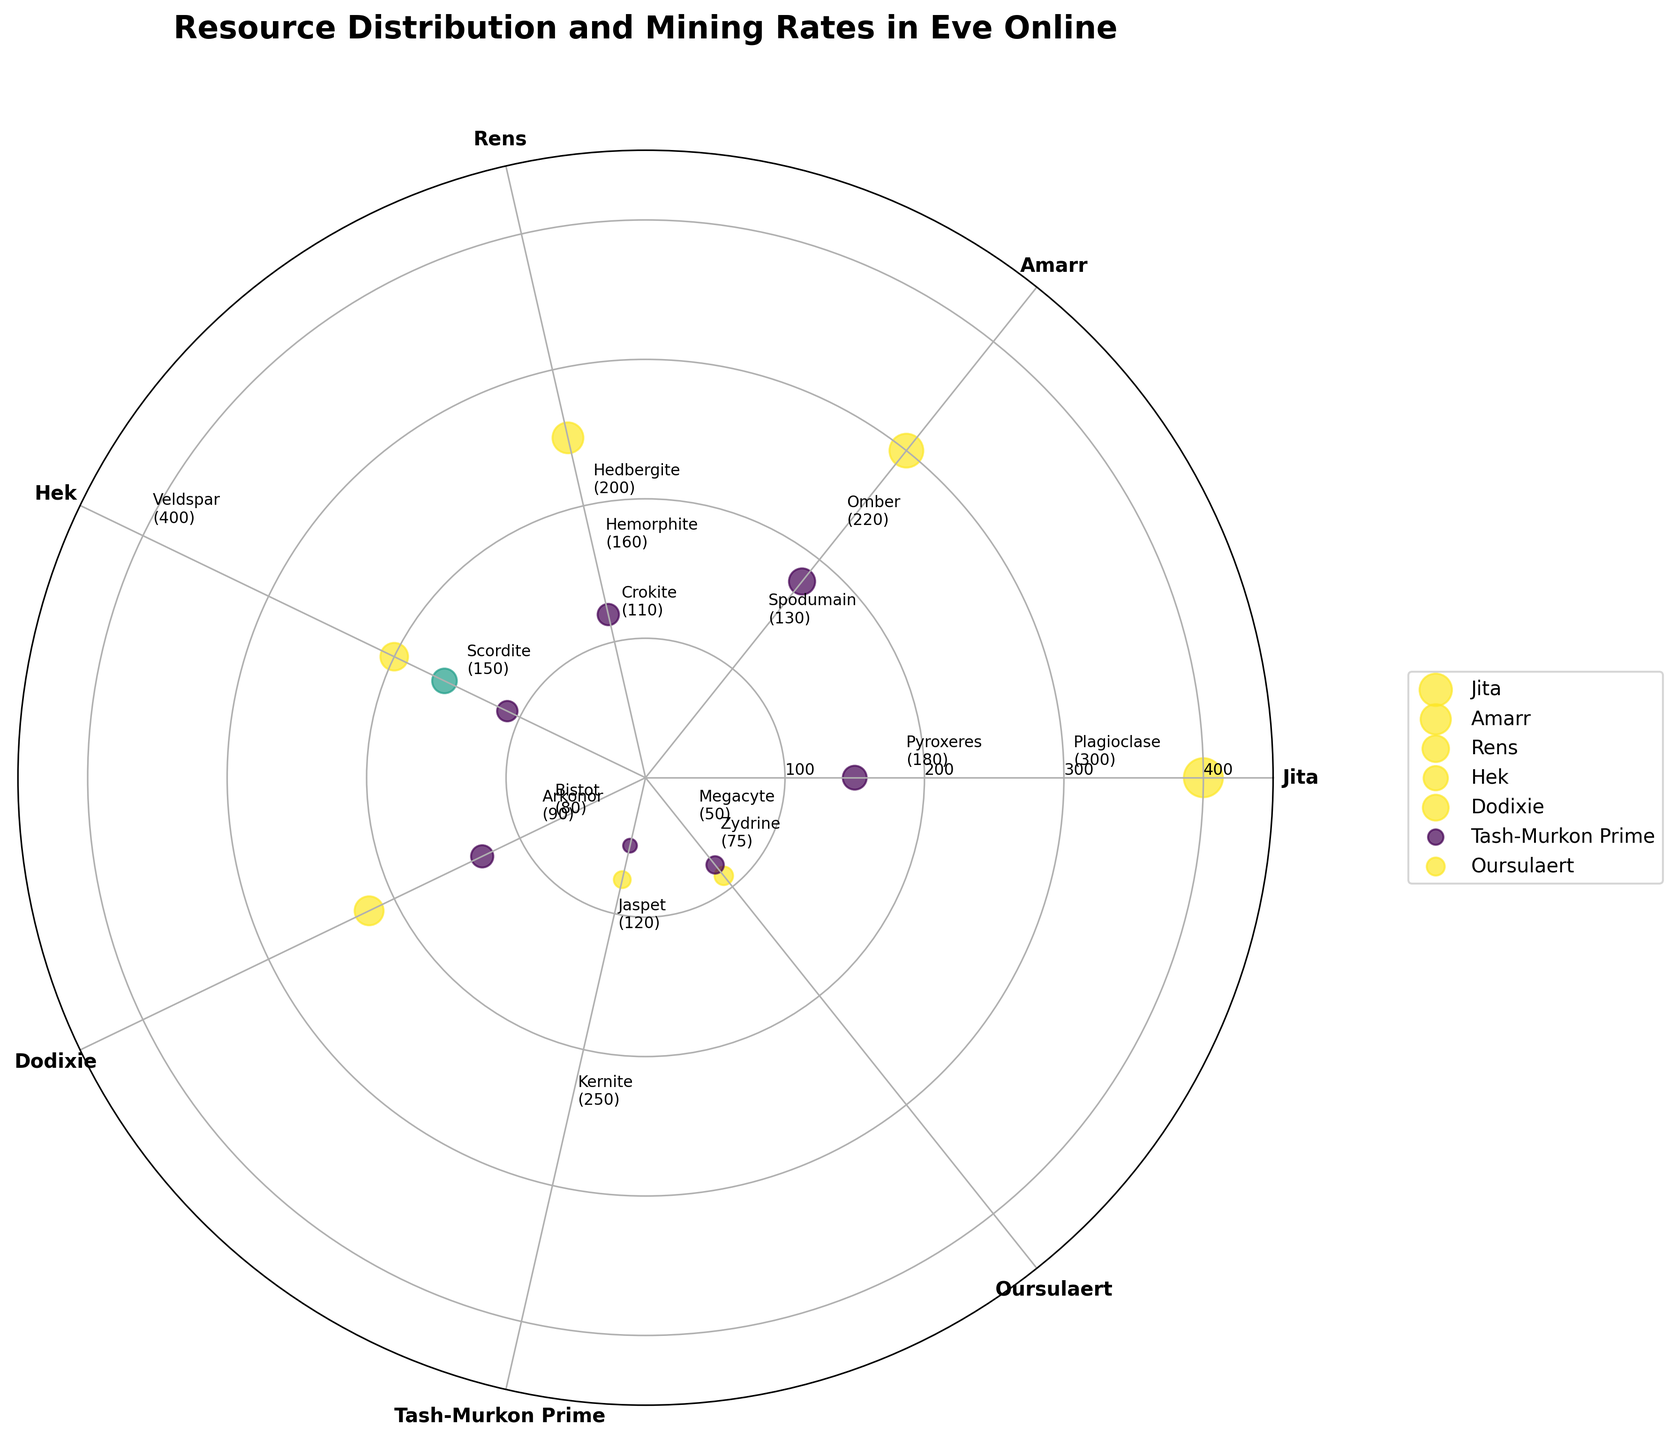What is the title of the plot? The title of the plot is clearly labeled at the top of the figure. It states: "Resource Distribution and Mining Rates in Eve Online".
Answer: Resource Distribution and Mining Rates in Eve Online Which star system has the highest mining rate for a single resource, and what is the rate? By examining the labels and values plotted around the circle, Jita has the highest mining rate for a single resource with Veldspar mined at a rate of 400.
Answer: Jita, 400 How many unique star systems are represented in the plot? The number of star systems can be determined by counting the different names on the circular axis. The unique star systems are Jita, Amarr, Rens, Hek, Dodixie, Tash-Murkon Prime, Oursulaert, resulting in seven unique star systems.
Answer: 7 What is the average mining rate for resources in Amarr? In Amarr, the resources are Plagioclase and Pyroxeres with mining rates of 300 and 180 respectively. The average mining rate is calculated as (300 + 180) / 2 = 240.
Answer: 240 Which resource has the lowest mining rate, and in which star system is it located? The resource with the lowest mining rate can be identified by looking for the smallest value around the circle. Megacyte in Tash-Murkon Prime has the lowest rate of 50.
Answer: Megacyte, Tash-Murkon Prime Which star system contains mining rates closest in value? By reviewing the mining rates, Oursulaert has Arkonor at 90 and Bistot at 80, which are closest in value with a difference of only 10 units.
Answer: Oursulaert Which star system has the widest range of mining rates, and what are the minimum and maximum rates? To find the widest range, note the minimum and maximum rates for each system. Jita has a minimum mining rate of 150 (Scordite) and a maximum of 400 (Veldspar), giving a range of 250.
Answer: Jita, Min: 150, Max: 400 What resource mined in Rens has the higher rate, and by how much? Comparing the mining rates for resources in Rens, Kernite has a rate of 250 and Jaspet has 120. Kernite's rate is higher by 250 - 120 = 130.
Answer: Kernite, 130 How many resources have a mining rate of 200 or more in Hek? In Hek, examining the resources, Hedbergite has a mining rate of 200 and Hemorphite has 160. Only Hedbergite has a rate of 200 or more.
Answer: 1 Which resource is mined in Dodixie at a higher rate, and what is the rate? In Dodixie, Omber has a mining rate of 220 and Spodumain 130. Omber has the higher mining rate of 220.
Answer: Omber, 220 